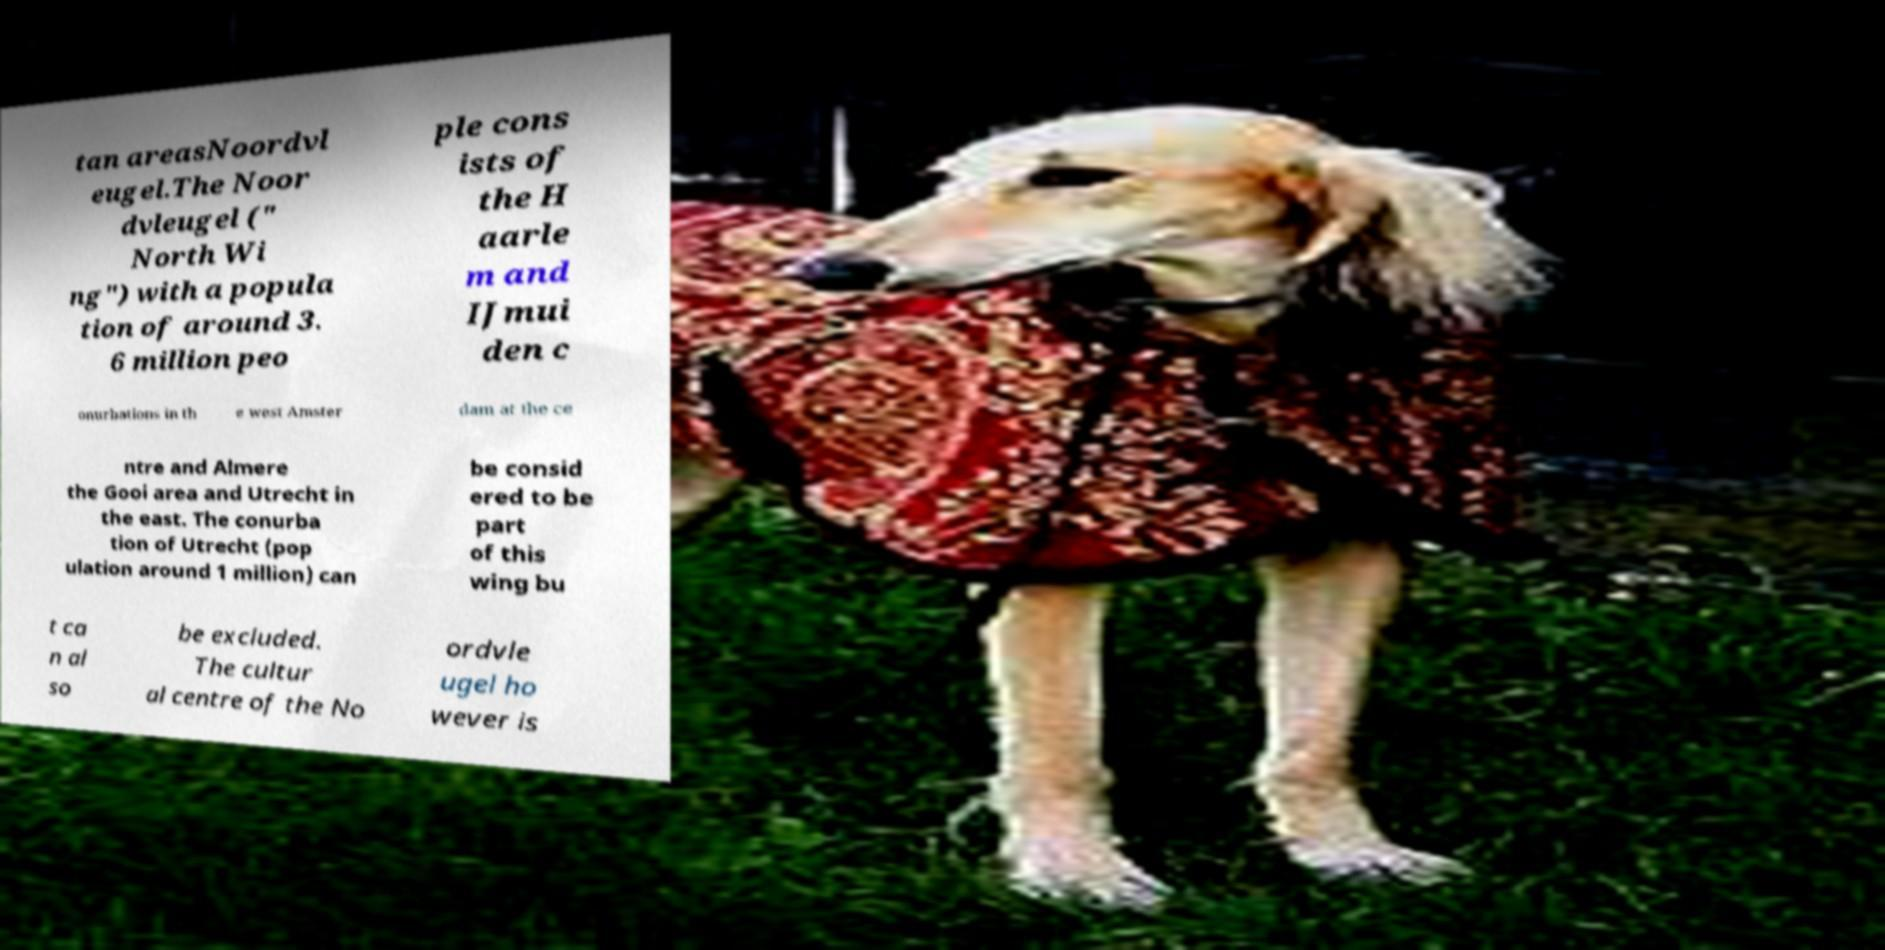Could you assist in decoding the text presented in this image and type it out clearly? tan areasNoordvl eugel.The Noor dvleugel (" North Wi ng") with a popula tion of around 3. 6 million peo ple cons ists of the H aarle m and IJmui den c onurbations in th e west Amster dam at the ce ntre and Almere the Gooi area and Utrecht in the east. The conurba tion of Utrecht (pop ulation around 1 million) can be consid ered to be part of this wing bu t ca n al so be excluded. The cultur al centre of the No ordvle ugel ho wever is 